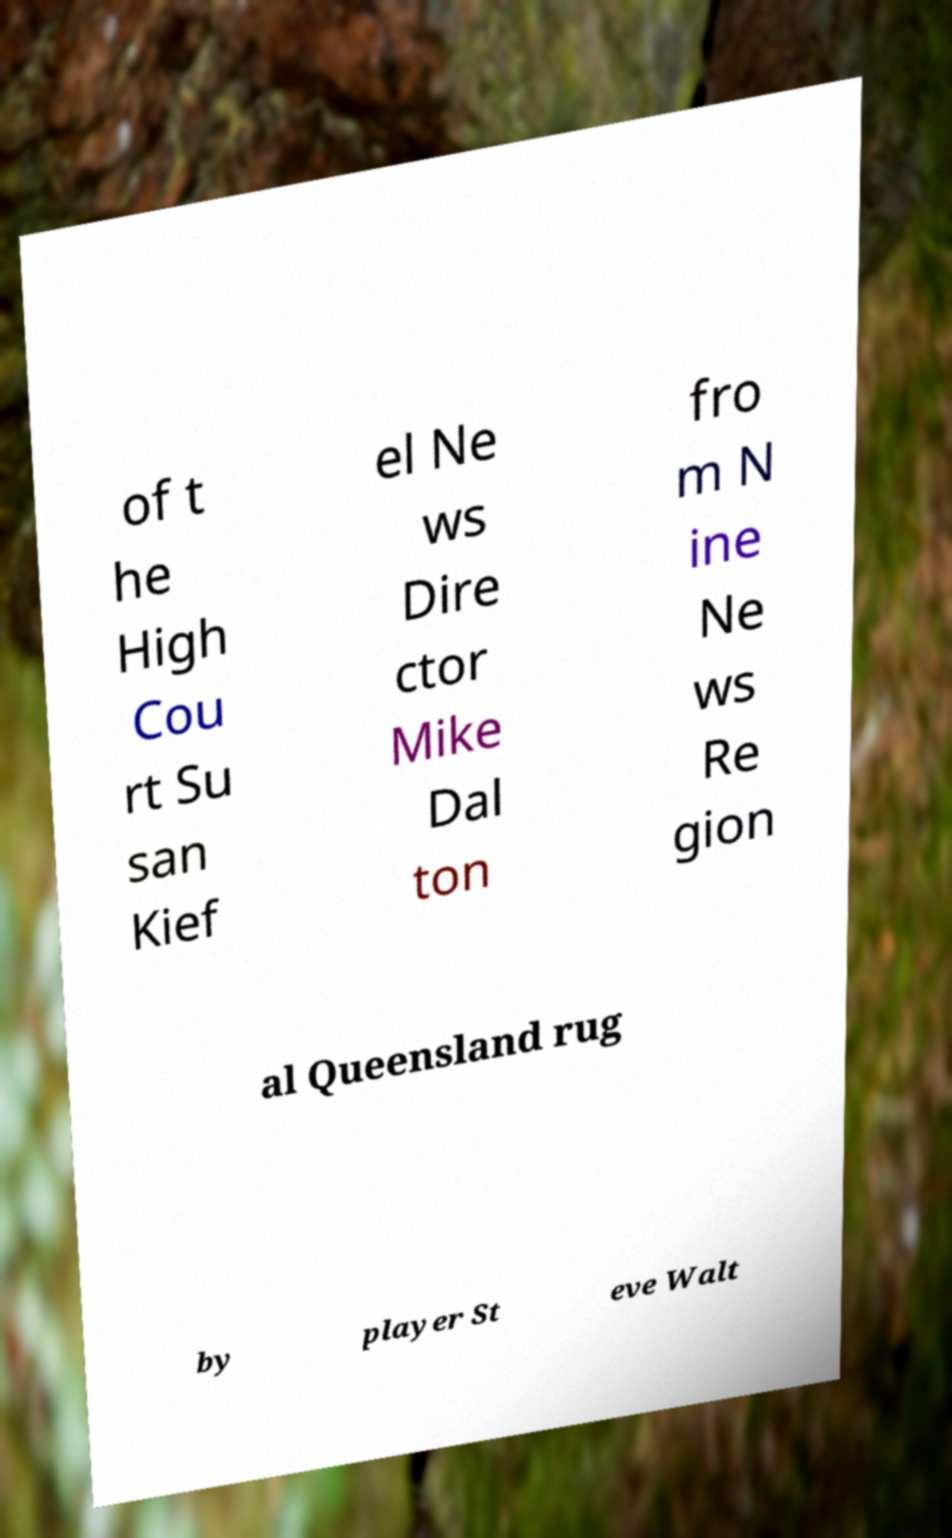What messages or text are displayed in this image? I need them in a readable, typed format. of t he High Cou rt Su san Kief el Ne ws Dire ctor Mike Dal ton fro m N ine Ne ws Re gion al Queensland rug by player St eve Walt 